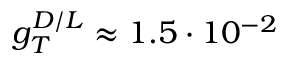<formula> <loc_0><loc_0><loc_500><loc_500>g _ { T } ^ { D / L } \approx 1 . 5 \cdot 1 0 ^ { - 2 }</formula> 